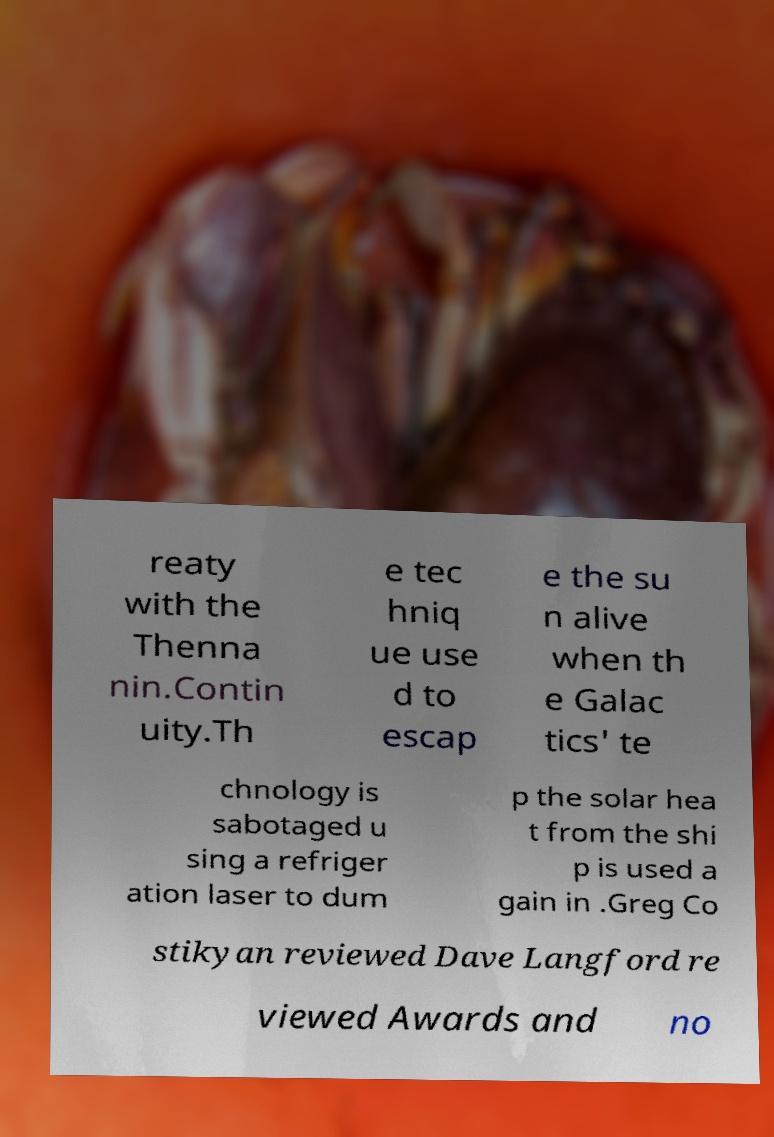What messages or text are displayed in this image? I need them in a readable, typed format. reaty with the Thenna nin.Contin uity.Th e tec hniq ue use d to escap e the su n alive when th e Galac tics' te chnology is sabotaged u sing a refriger ation laser to dum p the solar hea t from the shi p is used a gain in .Greg Co stikyan reviewed Dave Langford re viewed Awards and no 